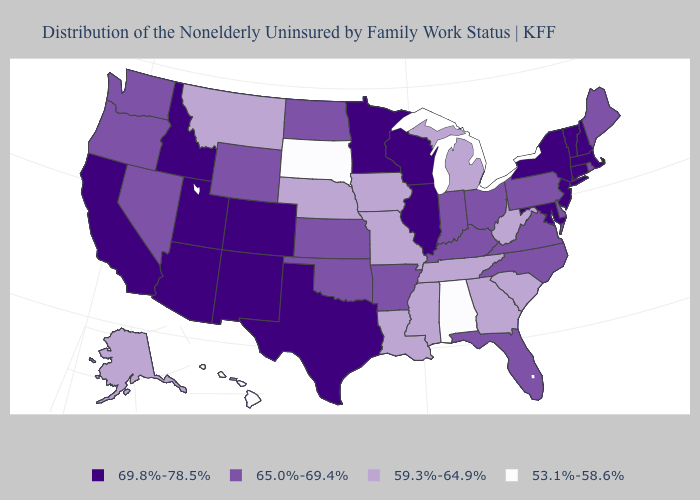What is the value of Nevada?
Concise answer only. 65.0%-69.4%. Name the states that have a value in the range 59.3%-64.9%?
Quick response, please. Alaska, Georgia, Iowa, Louisiana, Michigan, Mississippi, Missouri, Montana, Nebraska, South Carolina, Tennessee, West Virginia. Does Vermont have the highest value in the USA?
Concise answer only. Yes. What is the value of Vermont?
Write a very short answer. 69.8%-78.5%. Among the states that border Minnesota , which have the highest value?
Answer briefly. Wisconsin. Name the states that have a value in the range 59.3%-64.9%?
Give a very brief answer. Alaska, Georgia, Iowa, Louisiana, Michigan, Mississippi, Missouri, Montana, Nebraska, South Carolina, Tennessee, West Virginia. How many symbols are there in the legend?
Answer briefly. 4. What is the value of Massachusetts?
Write a very short answer. 69.8%-78.5%. Name the states that have a value in the range 59.3%-64.9%?
Give a very brief answer. Alaska, Georgia, Iowa, Louisiana, Michigan, Mississippi, Missouri, Montana, Nebraska, South Carolina, Tennessee, West Virginia. What is the value of Minnesota?
Answer briefly. 69.8%-78.5%. Name the states that have a value in the range 59.3%-64.9%?
Quick response, please. Alaska, Georgia, Iowa, Louisiana, Michigan, Mississippi, Missouri, Montana, Nebraska, South Carolina, Tennessee, West Virginia. Among the states that border Kentucky , which have the highest value?
Give a very brief answer. Illinois. What is the value of South Carolina?
Quick response, please. 59.3%-64.9%. Name the states that have a value in the range 59.3%-64.9%?
Keep it brief. Alaska, Georgia, Iowa, Louisiana, Michigan, Mississippi, Missouri, Montana, Nebraska, South Carolina, Tennessee, West Virginia. What is the highest value in states that border New Mexico?
Answer briefly. 69.8%-78.5%. 